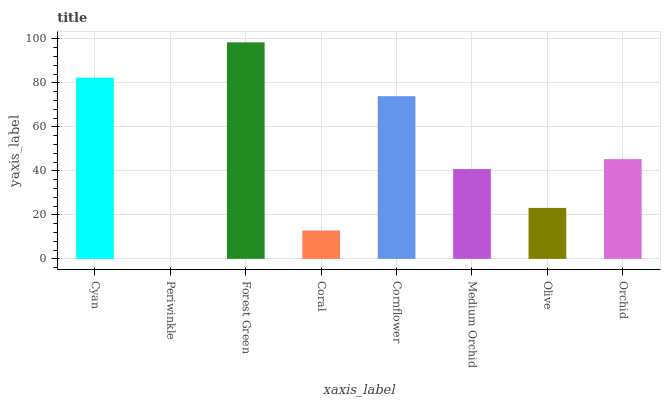Is Periwinkle the minimum?
Answer yes or no. Yes. Is Forest Green the maximum?
Answer yes or no. Yes. Is Forest Green the minimum?
Answer yes or no. No. Is Periwinkle the maximum?
Answer yes or no. No. Is Forest Green greater than Periwinkle?
Answer yes or no. Yes. Is Periwinkle less than Forest Green?
Answer yes or no. Yes. Is Periwinkle greater than Forest Green?
Answer yes or no. No. Is Forest Green less than Periwinkle?
Answer yes or no. No. Is Orchid the high median?
Answer yes or no. Yes. Is Medium Orchid the low median?
Answer yes or no. Yes. Is Medium Orchid the high median?
Answer yes or no. No. Is Cyan the low median?
Answer yes or no. No. 